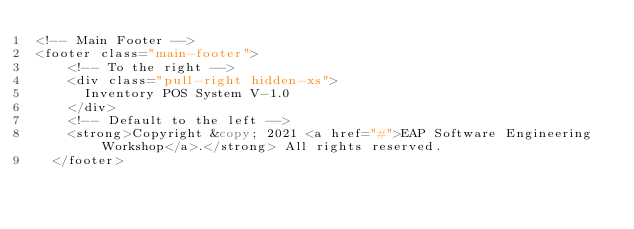<code> <loc_0><loc_0><loc_500><loc_500><_PHP_><!-- Main Footer -->
<footer class="main-footer">
    <!-- To the right -->
    <div class="pull-right hidden-xs">
      Inventory POS System V-1.0
    </div>
    <!-- Default to the left -->
    <strong>Copyright &copy; 2021 <a href="#">EAP Software Engineering Workshop</a>.</strong> All rights reserved.
  </footer>

  </code> 